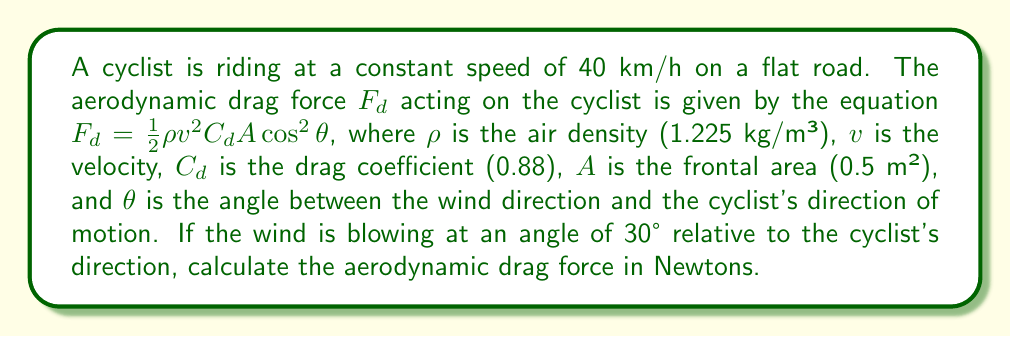Could you help me with this problem? To solve this problem, we'll follow these steps:

1) First, let's convert the cyclist's speed from km/h to m/s:
   $v = 40 \text{ km/h} = 40 \times \frac{1000 \text{ m}}{3600 \text{ s}} = \frac{40000}{3600} = \frac{100}{9} \approx 11.11 \text{ m/s}$

2) Now, let's substitute the given values into the drag force equation:
   $F_d = \frac{1}{2}\rho v^2 C_d A \cos^2\theta$

   Where:
   $\rho = 1.225 \text{ kg/m³}$
   $v = \frac{100}{9} \text{ m/s}$
   $C_d = 0.88$
   $A = 0.5 \text{ m²}$
   $\theta = 30°$

3) Calculate $\cos^2\theta$:
   $\cos^2(30°) = (\frac{\sqrt{3}}{2})^2 = \frac{3}{4}$

4) Now, let's substitute all values into the equation:
   $$F_d = \frac{1}{2} \times 1.225 \times (\frac{100}{9})^2 \times 0.88 \times 0.5 \times \frac{3}{4}$$

5) Simplify:
   $$F_d = \frac{1.225 \times 10000 \times 0.88 \times 0.5 \times 3}{2 \times 81 \times 4} = \frac{1617000}{648} = 2495.37 \text{ N}$$

6) Round to two decimal places:
   $F_d \approx 2495.37 \text{ N}$
Answer: 2495.37 N 